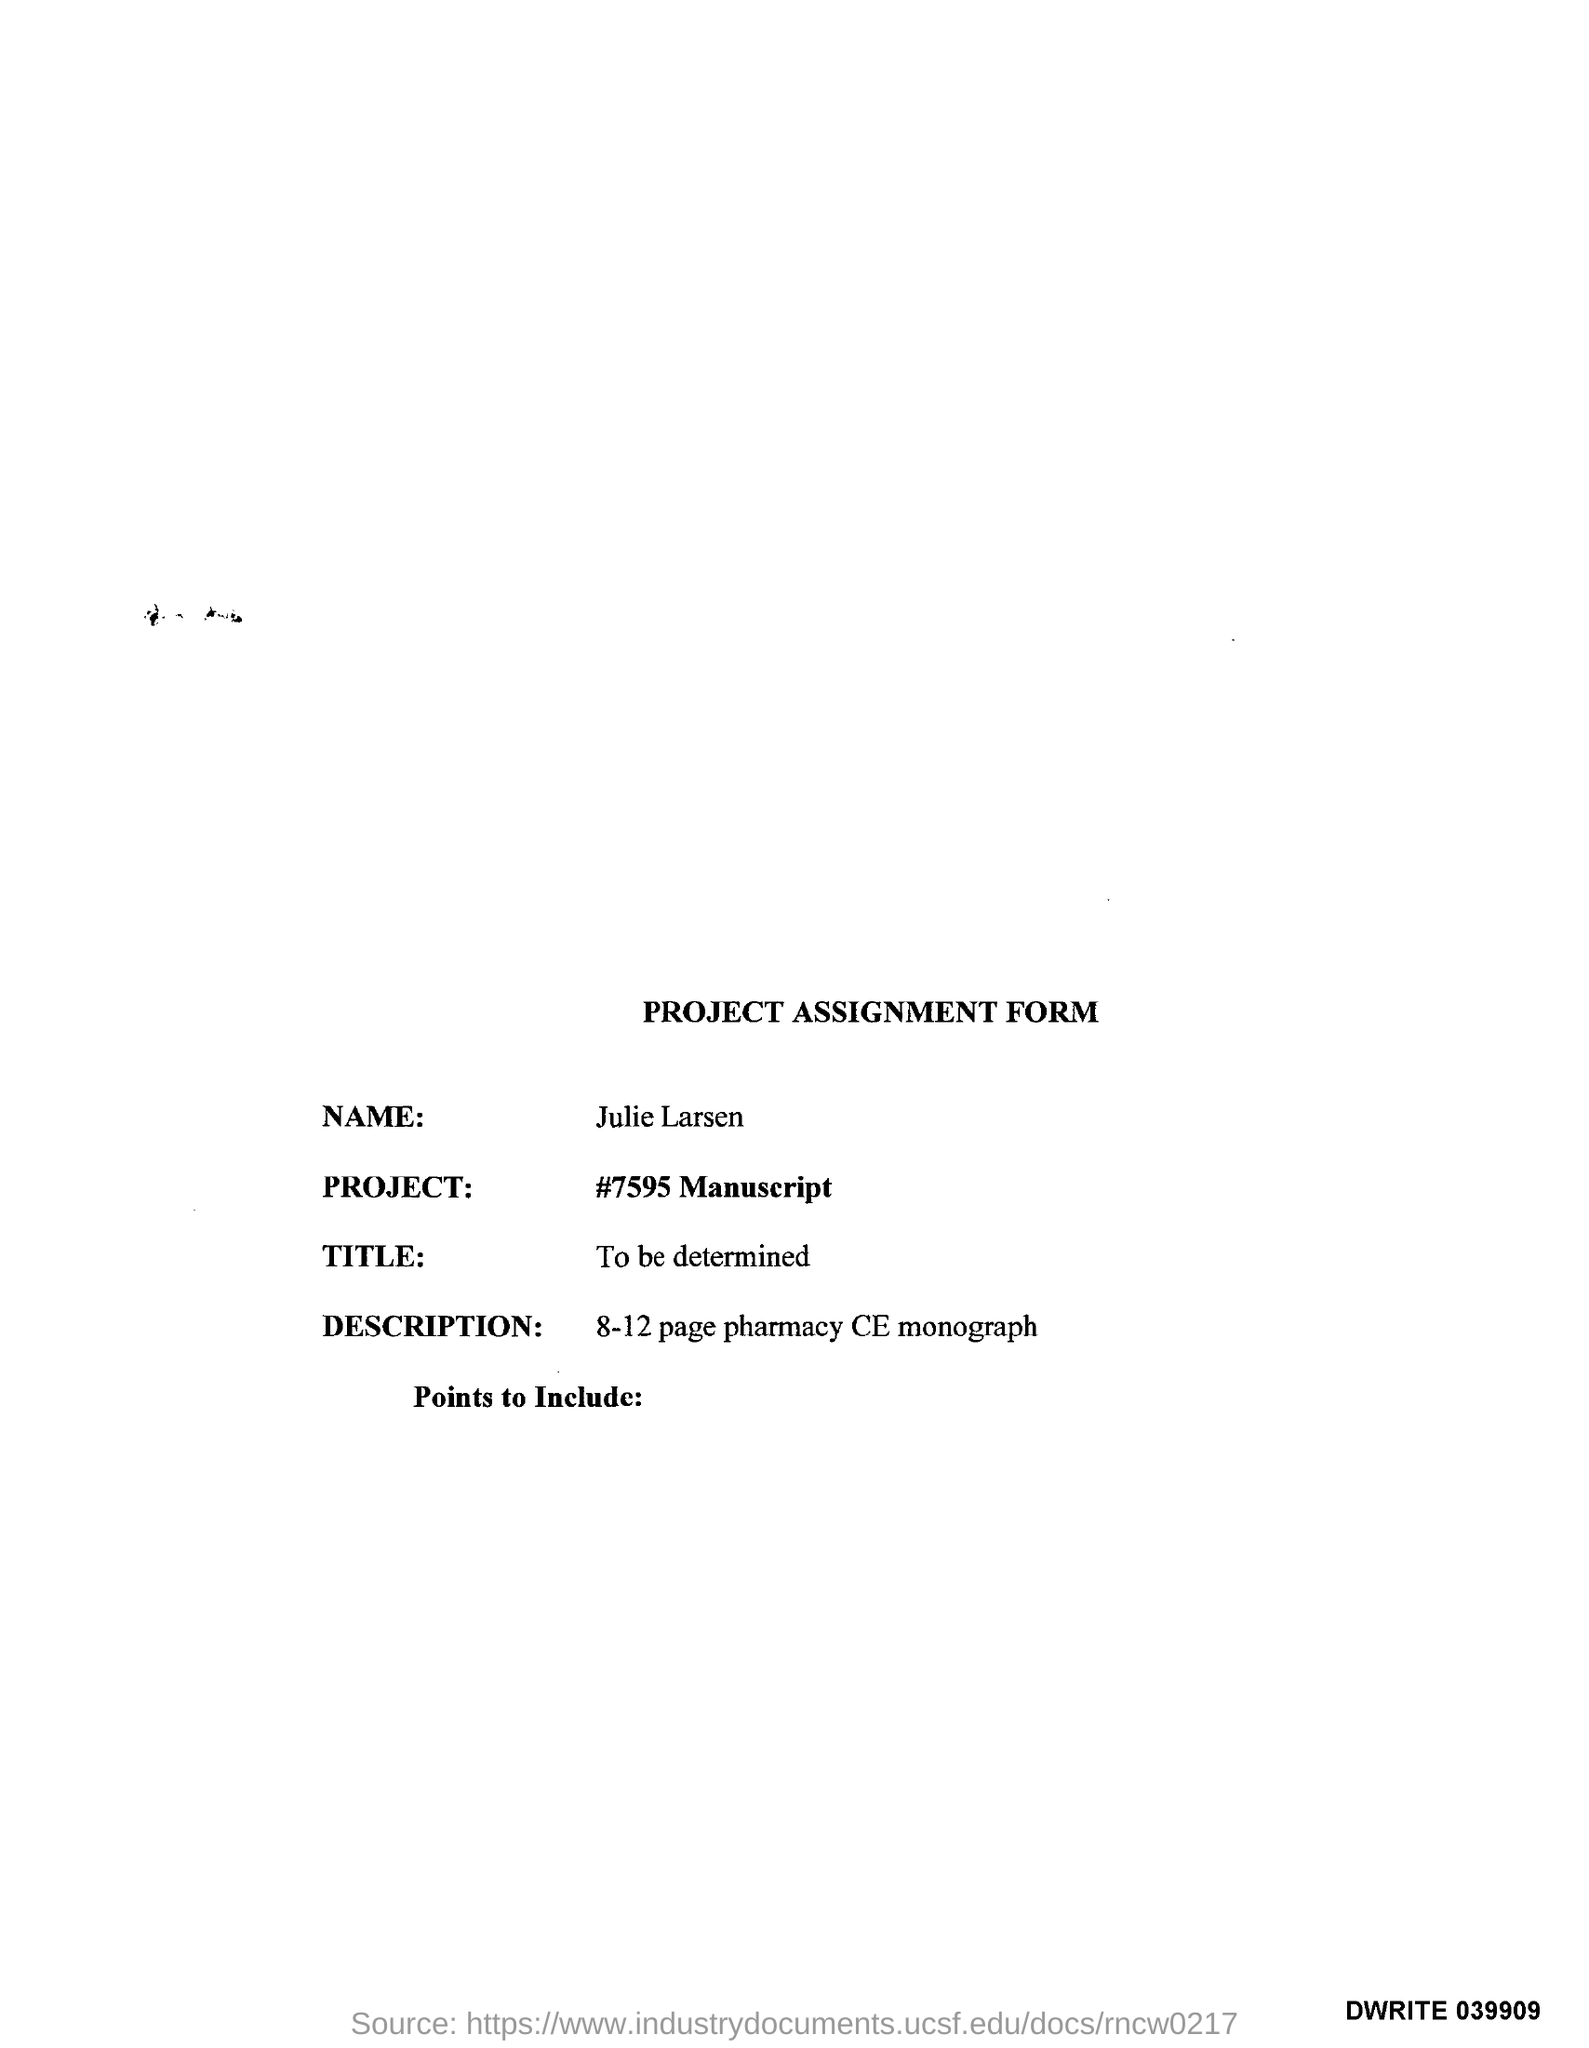Who assigned this project?
Give a very brief answer. Julie Larsen. What is the name of the project?
Give a very brief answer. #7595 Manuscript. What is the description of this form?
Give a very brief answer. 8-12 page pharmacy CE monograph. 